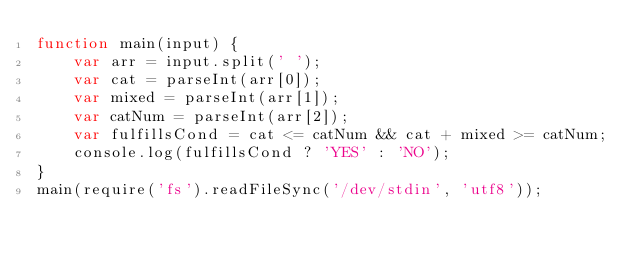<code> <loc_0><loc_0><loc_500><loc_500><_JavaScript_>function main(input) {
    var arr = input.split(' ');
    var cat = parseInt(arr[0]);
    var mixed = parseInt(arr[1]);
    var catNum = parseInt(arr[2]);
    var fulfillsCond = cat <= catNum && cat + mixed >= catNum;
    console.log(fulfillsCond ? 'YES' : 'NO');
}
main(require('fs').readFileSync('/dev/stdin', 'utf8'));</code> 